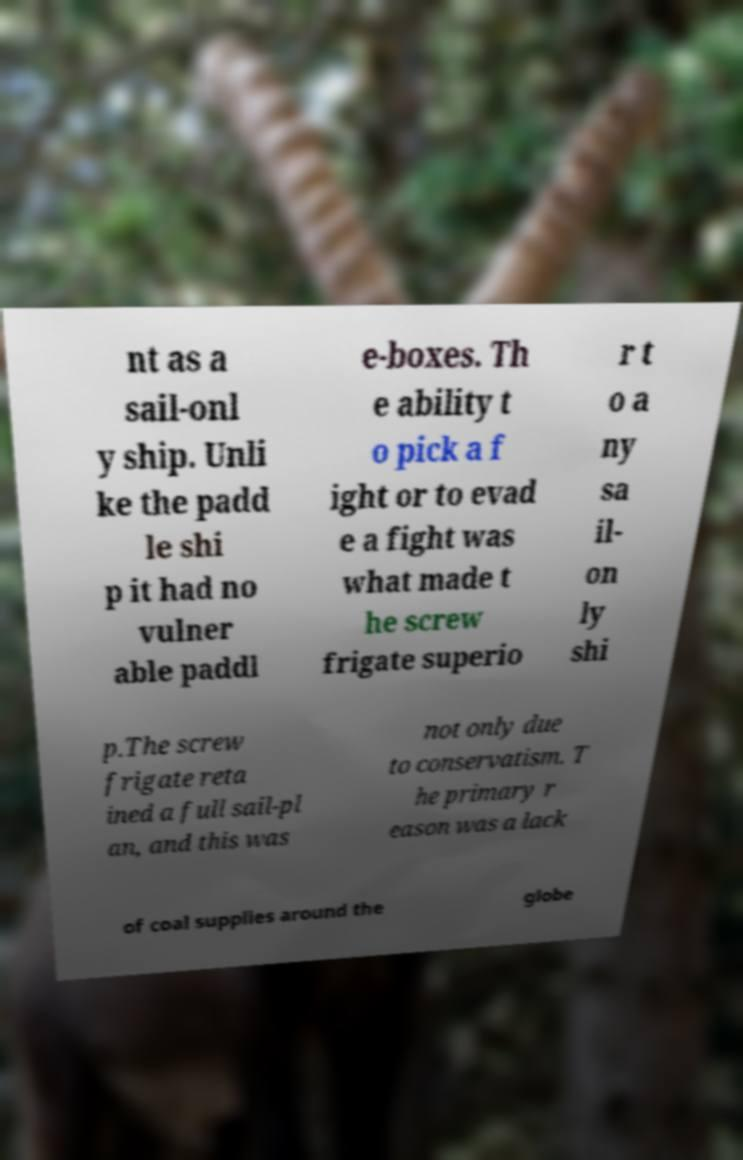I need the written content from this picture converted into text. Can you do that? nt as a sail-onl y ship. Unli ke the padd le shi p it had no vulner able paddl e-boxes. Th e ability t o pick a f ight or to evad e a fight was what made t he screw frigate superio r t o a ny sa il- on ly shi p.The screw frigate reta ined a full sail-pl an, and this was not only due to conservatism. T he primary r eason was a lack of coal supplies around the globe 